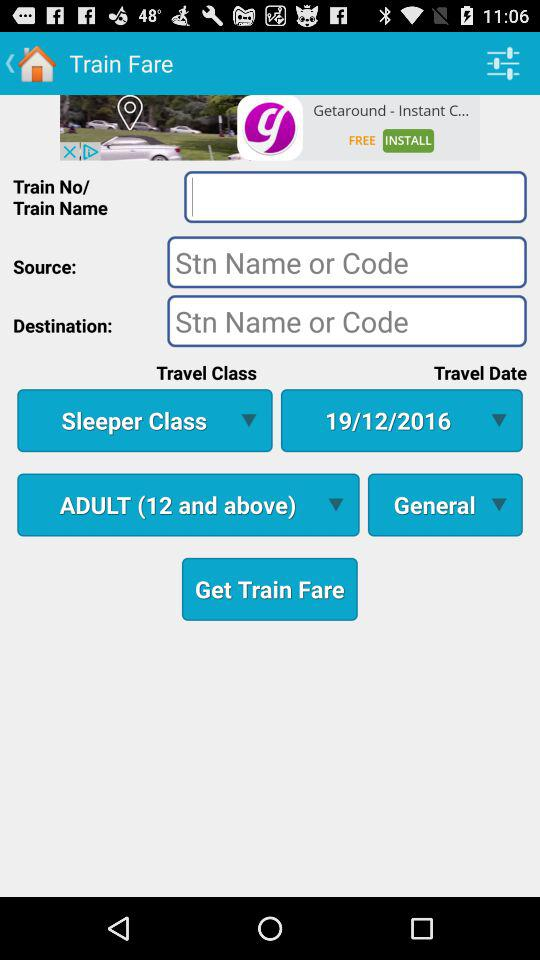How many text inputs are there for the source and destination?
Answer the question using a single word or phrase. 2 